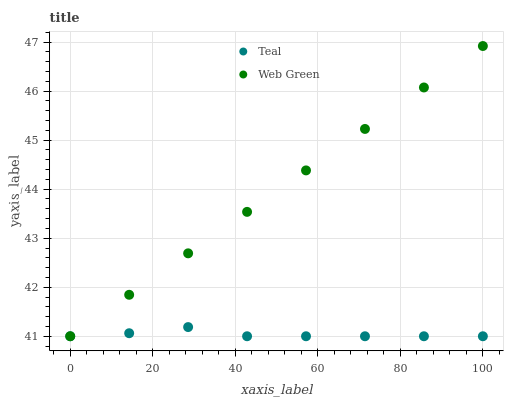Does Teal have the minimum area under the curve?
Answer yes or no. Yes. Does Web Green have the maximum area under the curve?
Answer yes or no. Yes. Does Teal have the maximum area under the curve?
Answer yes or no. No. Is Web Green the smoothest?
Answer yes or no. Yes. Is Teal the roughest?
Answer yes or no. Yes. Is Teal the smoothest?
Answer yes or no. No. Does Web Green have the lowest value?
Answer yes or no. Yes. Does Web Green have the highest value?
Answer yes or no. Yes. Does Teal have the highest value?
Answer yes or no. No. Does Web Green intersect Teal?
Answer yes or no. Yes. Is Web Green less than Teal?
Answer yes or no. No. Is Web Green greater than Teal?
Answer yes or no. No. 